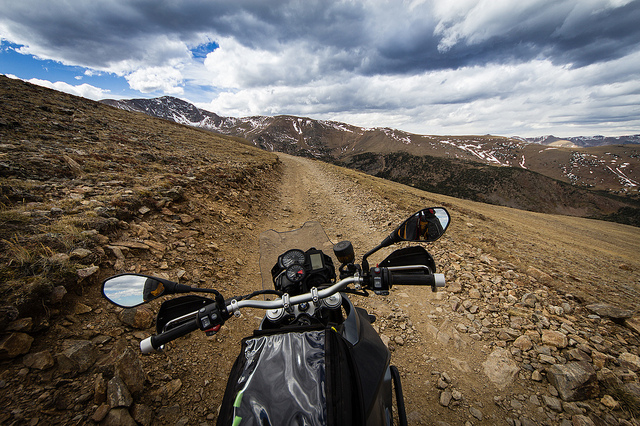What kind of terrain is the bike traveling on? The bike is on a rugged dirt road, indicative of off-road trail conditions, likely challenging for travel due to loose rocks and the uneven surface. 